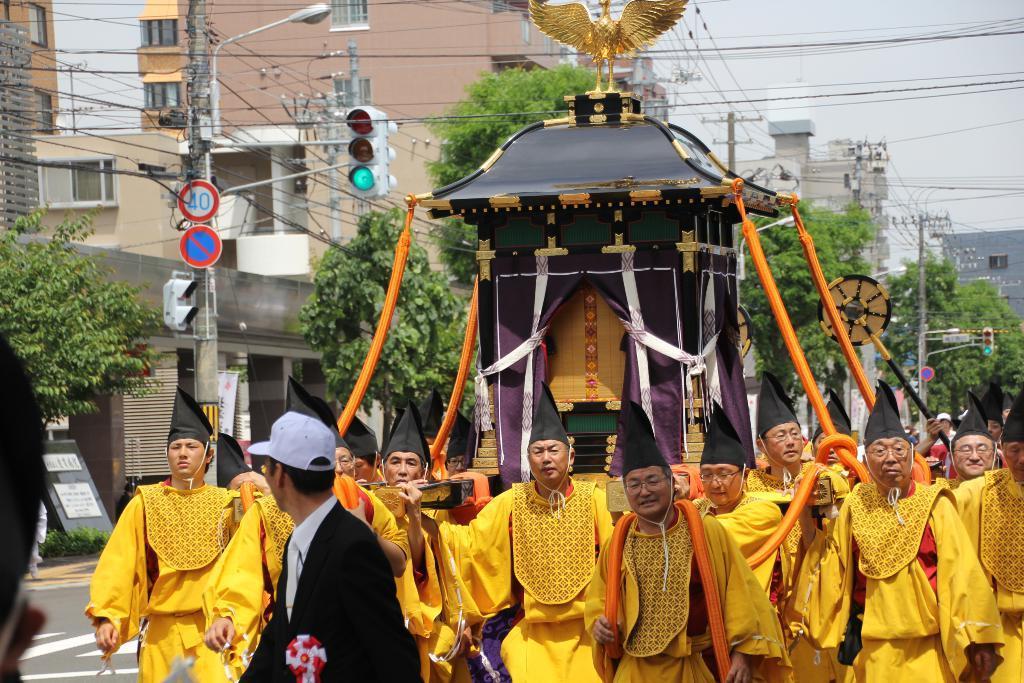Please provide a concise description of this image. In the image there are many people carrying a chariot. And there are few people with caps on their heads. On the chariot there is a statue of a bird. Behind them there are many trees, electrical poles with wires, sign boards, traffic signals and wires. Behind them there are buildings. 